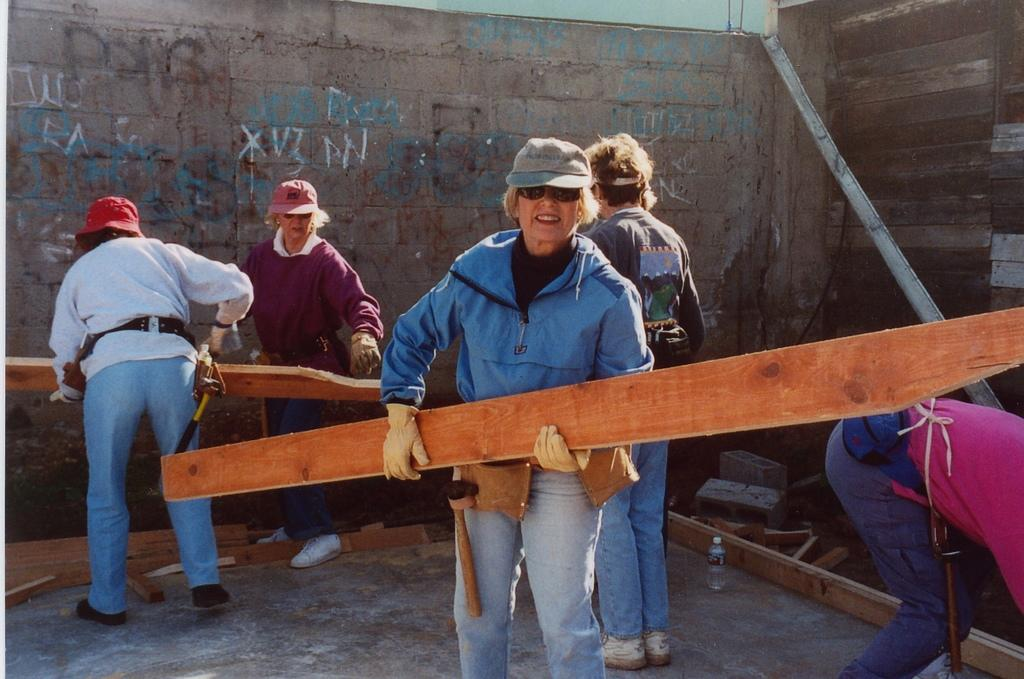Who is the main subject in the foreground of the image? There is a lady in the foreground of the image. What is the lady holding in the image? The lady is holding a wooden stick. What can be seen in the background of the image? There are people, walls, and some objects in the background of the image. What type of wind can be seen blowing in the image? There is no wind visible in the image. Who has the authority over the people in the background of the image? The image does not provide any information about the authority or hierarchy among the people in the background. 